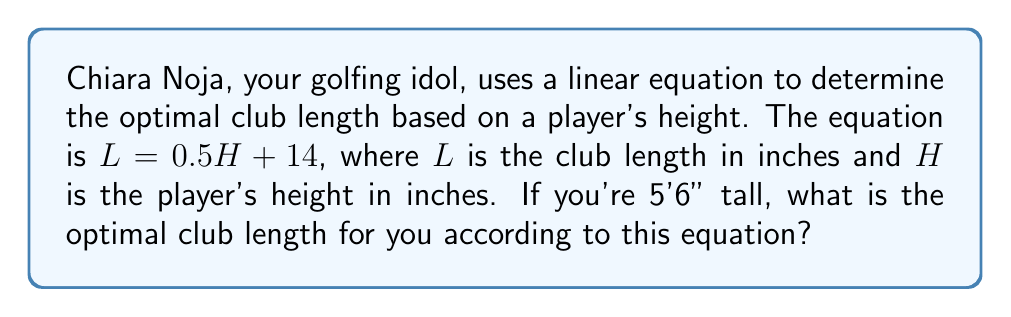Help me with this question. To solve this problem, we'll follow these steps:

1) First, we need to convert your height from feet and inches to just inches:
   5'6" = (5 × 12) + 6 = 66 inches

2) Now we can use the given equation: $L = 0.5H + 14$
   Where $L$ is the club length and $H$ is the height in inches

3) Substitute your height (66 inches) into the equation:
   $L = 0.5(66) + 14$

4) Simplify:
   $L = 33 + 14$
   $L = 47$

Therefore, the optimal club length for you would be 47 inches.
Answer: 47 inches 